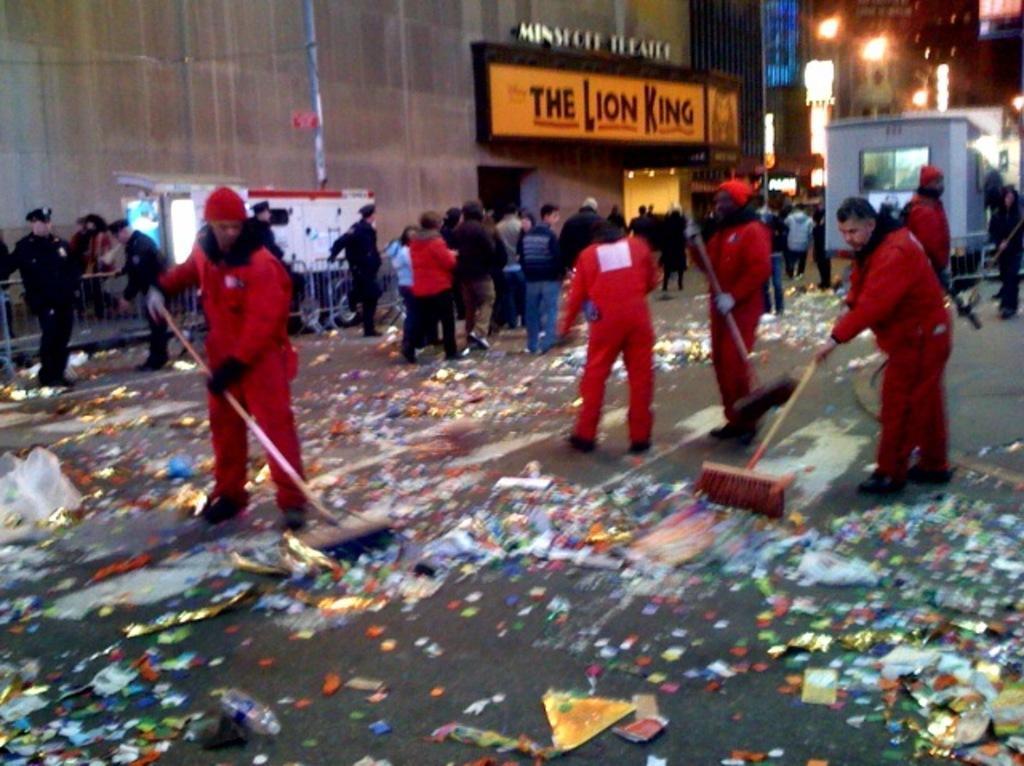Could you give a brief overview of what you see in this image? This is a blur image. In this image I can see a group of people on the road among them, some people are cleaning the road and some of them are walking. I can see the buildings with some text and lights at the top of the image. 